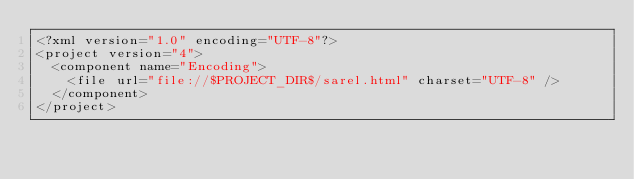<code> <loc_0><loc_0><loc_500><loc_500><_XML_><?xml version="1.0" encoding="UTF-8"?>
<project version="4">
  <component name="Encoding">
    <file url="file://$PROJECT_DIR$/sarel.html" charset="UTF-8" />
  </component>
</project></code> 